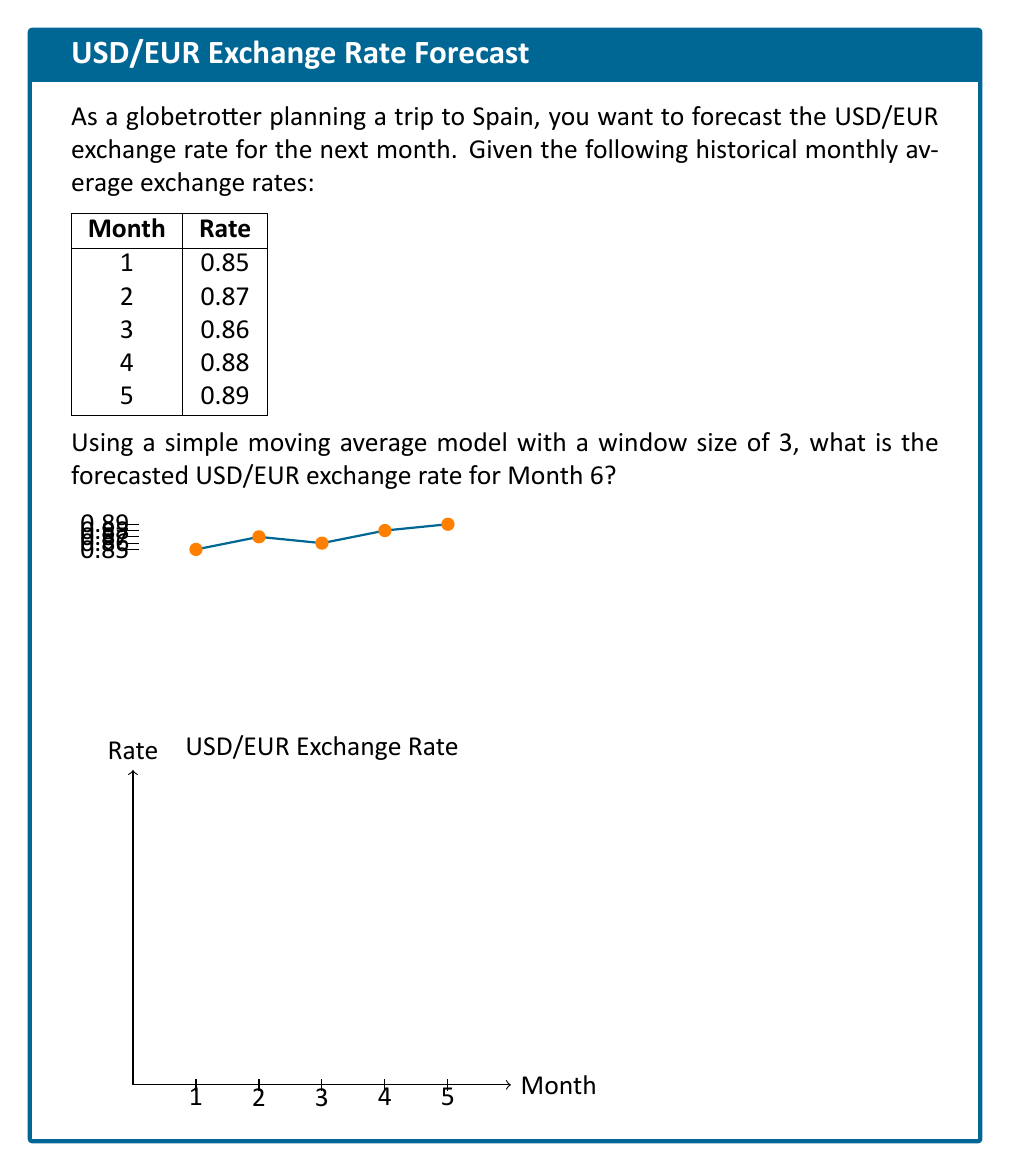Can you answer this question? To forecast the exchange rate using a simple moving average model with a window size of 3, we follow these steps:

1) First, let's understand what a simple moving average (SMA) with a window size of 3 means. It's the average of the last 3 data points.

2) To forecast Month 6, we'll use the data from Months 3, 4, and 5.

3) Calculate the SMA:
   $$SMA = \frac{Month_3 + Month_4 + Month_5}{3}$$

4) Plug in the values:
   $$SMA = \frac{0.86 + 0.88 + 0.89}{3}$$

5) Perform the calculation:
   $$SMA = \frac{2.63}{3} = 0.8766666...$$

6) Round to 4 decimal places (common for exchange rates):
   $$SMA \approx 0.8767$$

This value, 0.8767, is our forecast for the USD/EUR exchange rate in Month 6.

Note: This simple model assumes that the trend observed in the last three months will continue. In reality, exchange rates are influenced by many complex factors and more sophisticated models are often used for more accurate predictions.
Answer: 0.8767 